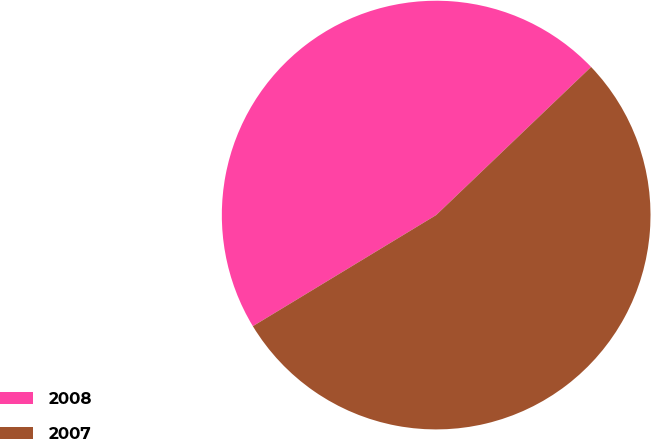Convert chart. <chart><loc_0><loc_0><loc_500><loc_500><pie_chart><fcel>2008<fcel>2007<nl><fcel>46.53%<fcel>53.47%<nl></chart> 